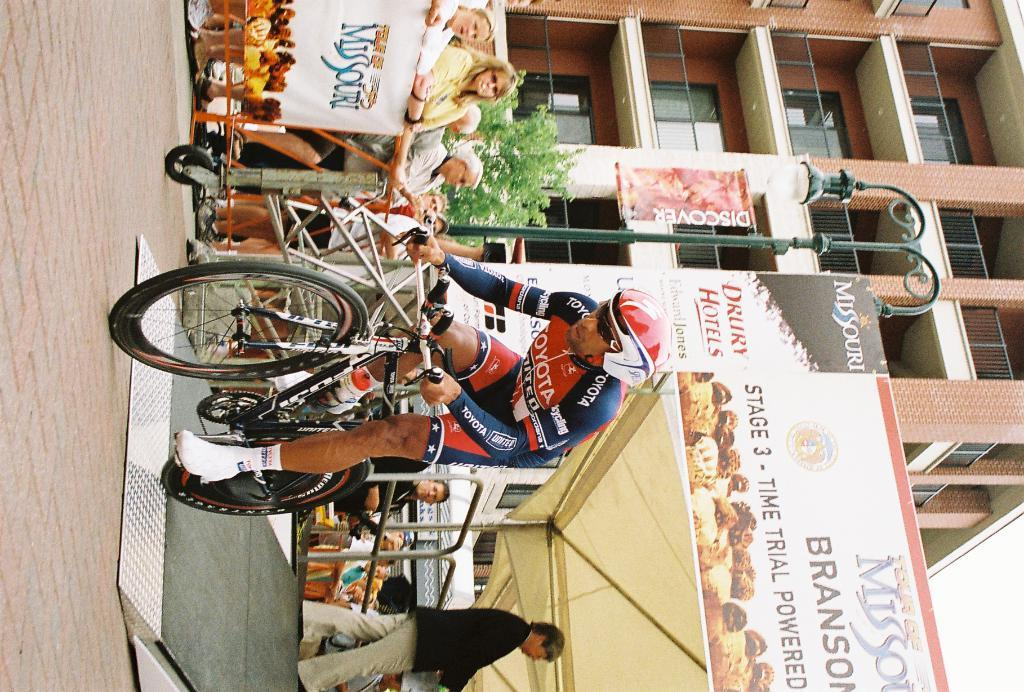What is the man in the image doing? The man is riding a cycle in the image. Can you describe the surroundings of the man? There are a lot of people behind the man, and there is a banner, a pole with two lights, a tree, and a building behind the tree. What can be seen on the pole in the image? There are two lights on the pole in the image. What type of structure is visible behind the tree? There is a building behind the tree. What type of marble is used to decorate the building in the image? There is no marble visible in the image, and the building is not described as having any marble decoration. 